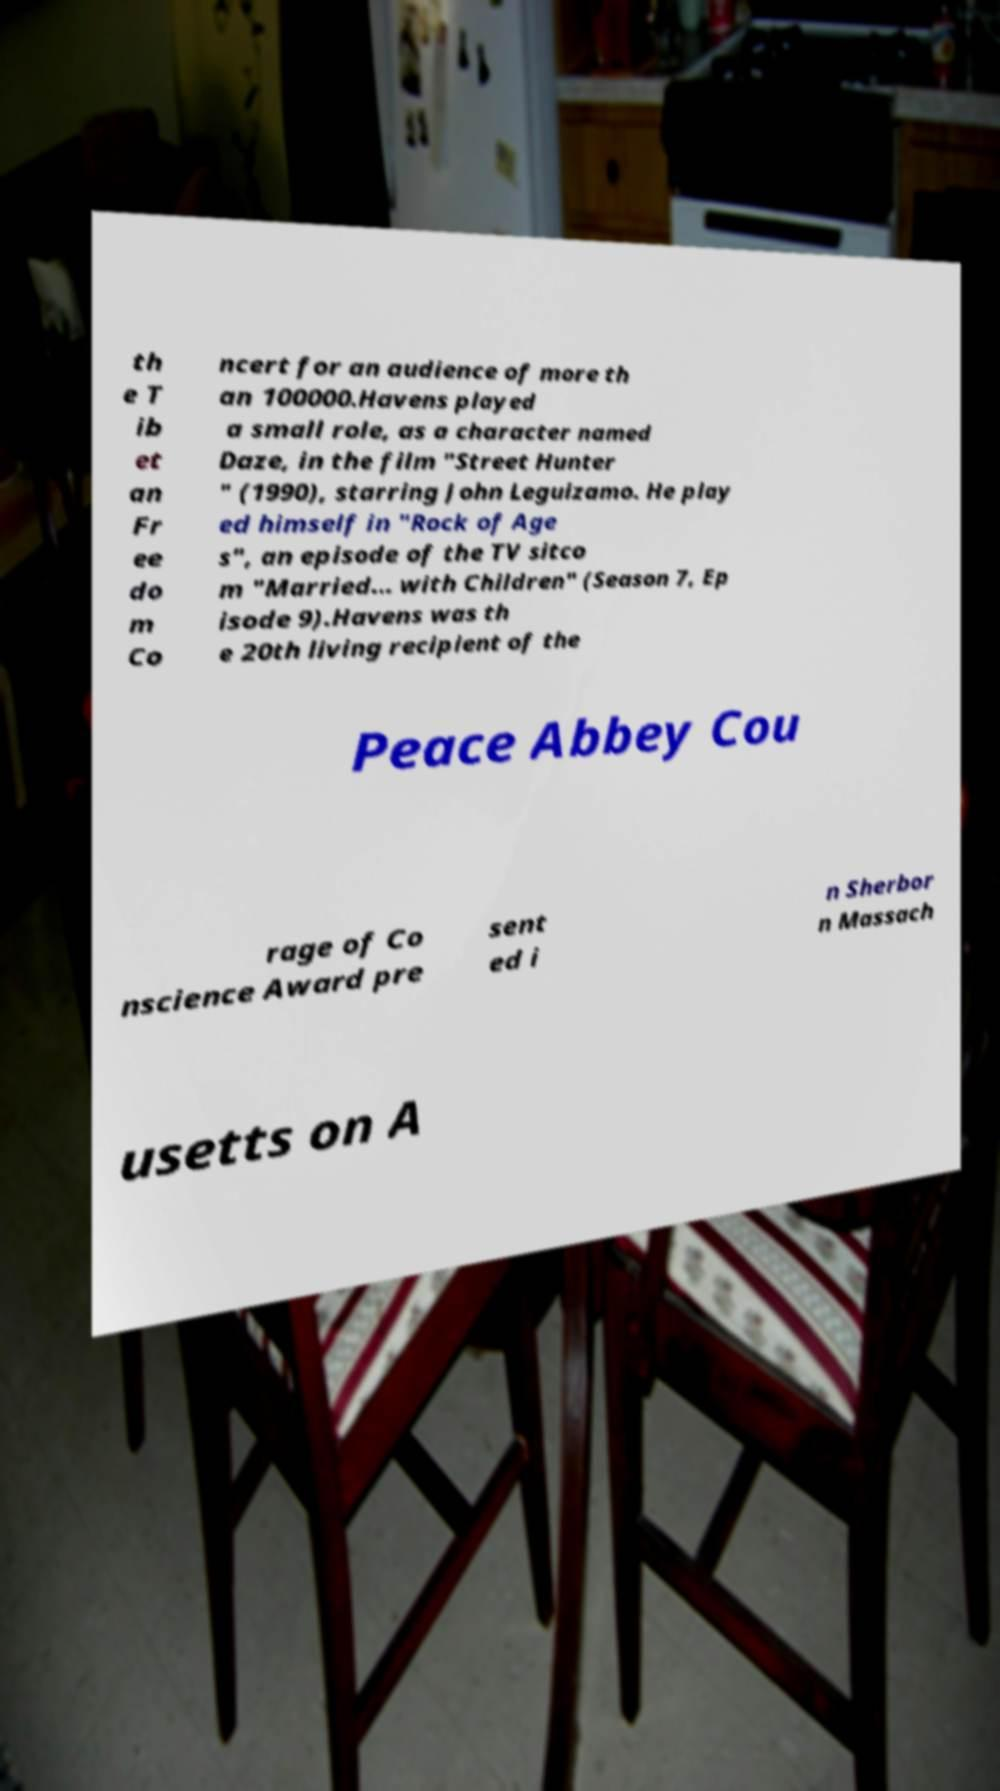Could you assist in decoding the text presented in this image and type it out clearly? th e T ib et an Fr ee do m Co ncert for an audience of more th an 100000.Havens played a small role, as a character named Daze, in the film "Street Hunter " (1990), starring John Leguizamo. He play ed himself in "Rock of Age s", an episode of the TV sitco m "Married... with Children" (Season 7, Ep isode 9).Havens was th e 20th living recipient of the Peace Abbey Cou rage of Co nscience Award pre sent ed i n Sherbor n Massach usetts on A 